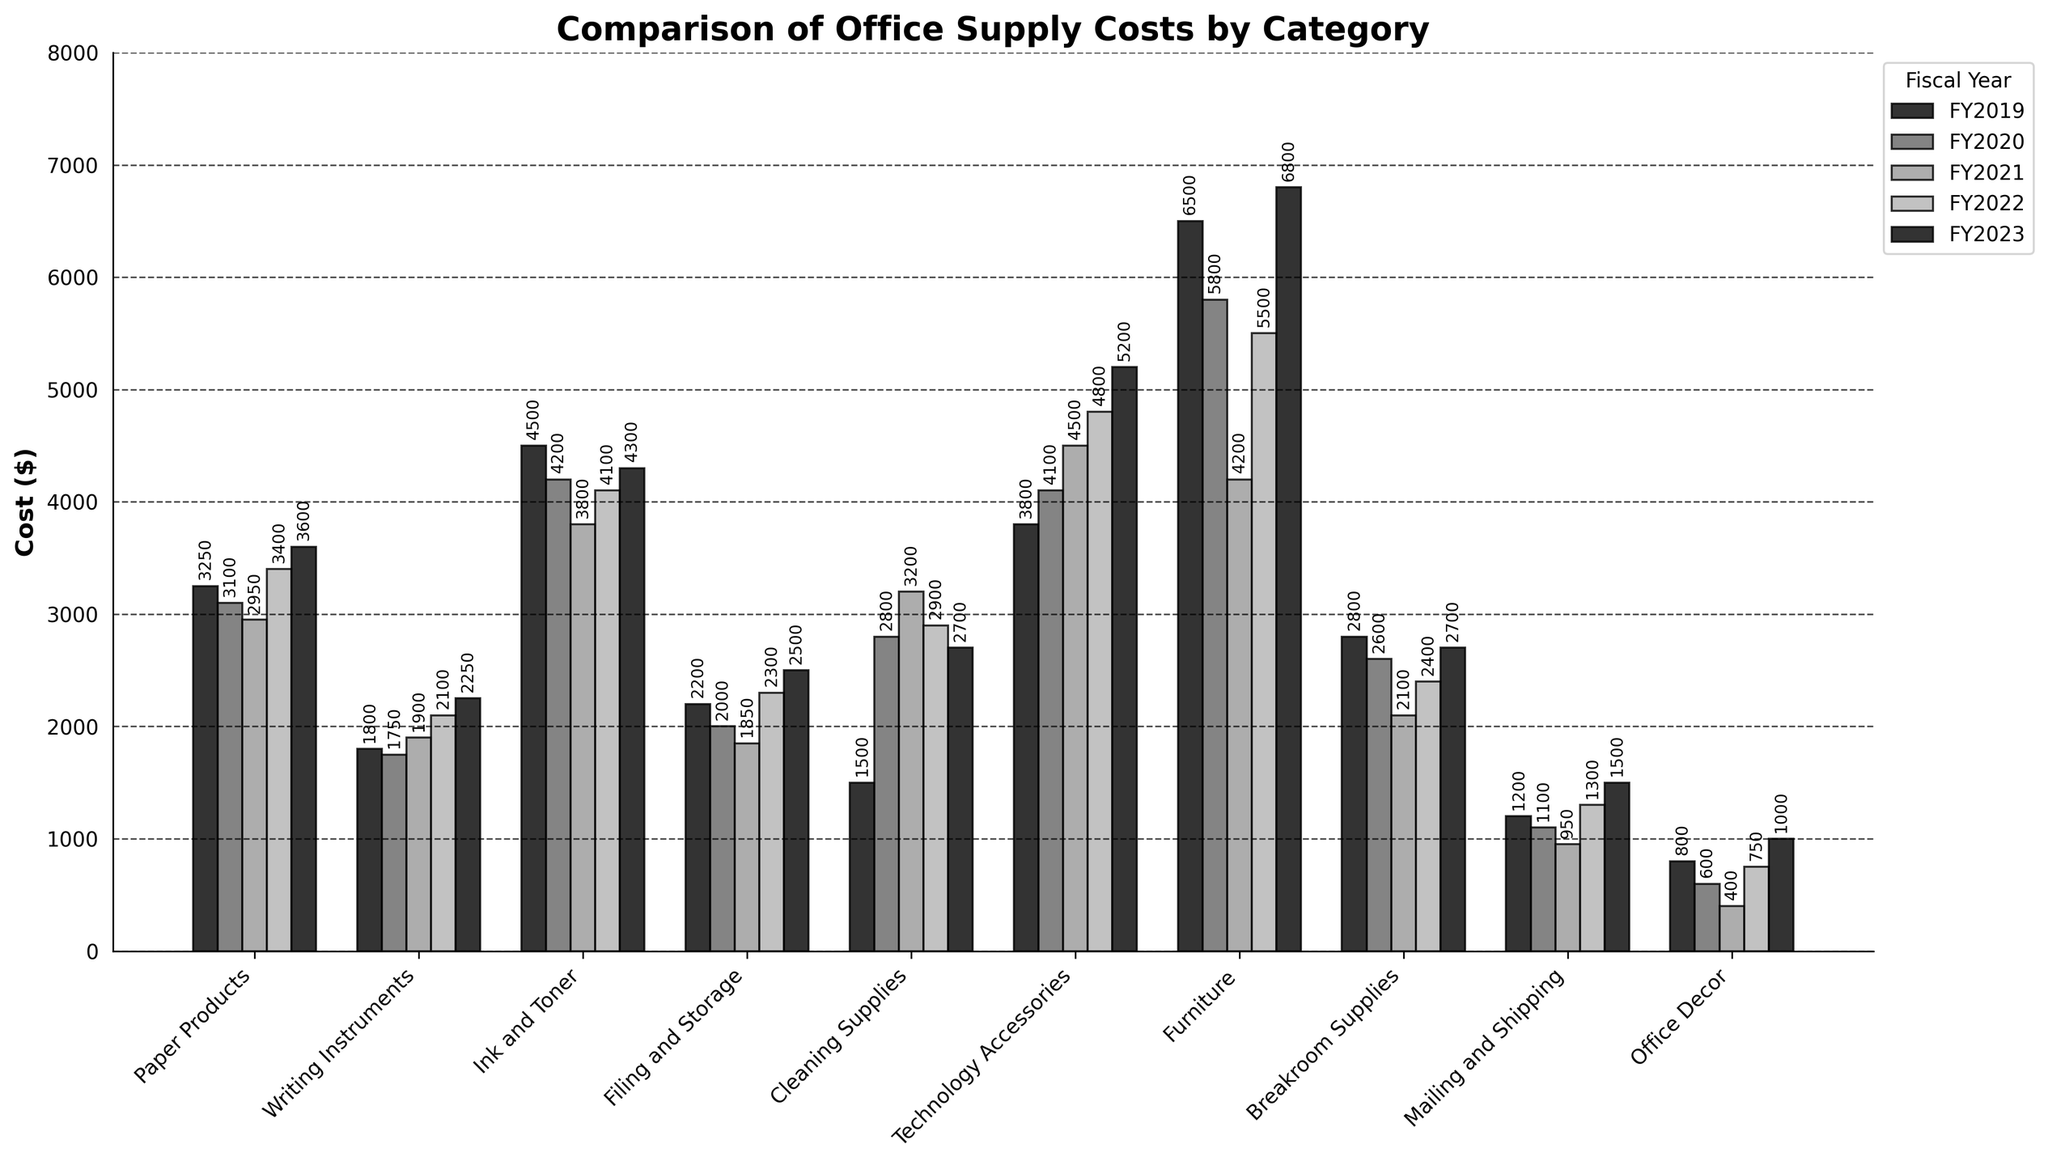What's the highest cost category in FY2023? Look for the tallest bar in FY2023. The 'Furniture' category has the tallest bar in FY2023, indicating the highest cost.
Answer: Furniture Which category had the most significant increase in cost from FY2019 to FY2023? Compare each category's cost in FY2019 and FY2023. The category with the largest difference is 'Furniture' which increased from 6500 to 6800.
Answer: Furniture What is the total cost for 'Cleaning Supplies' between FY2019 and FY2023? Add the costs for 'Cleaning Supplies' for each fiscal year: 1500 (FY2019) + 2800 (FY2020) + 3200 (FY2021) + 2900 (FY2022) + 2700 (FY2023) = 13100.
Answer: 13100 Which categories saw a cost decrease from FY2019 to FY2023? Compare the costs of each category from FY2019 to FY2023. Categories that decreased include 'Writing Instruments', 'Ink and Toner', 'Filing and Storage', 'Breakroom Supplies', and 'Office Decor'.
Answer: Writing Instruments, Ink and Toner, Filing and Storage, Breakroom Supplies, Office Decor What is the average cost for 'Technology Accessories' over the last 5 fiscal years? Add the costs for 'Technology Accessories' and divide by 5: (3800 + 4100 + 4500 + 4800 + 5200) / 5 = 4480.
Answer: 4480 Which category had the lowest cost in FY2021? Look for the shortest bar in FY2021. The 'Office Decor' category has the shortest bar in FY2021, indicating the lowest cost.
Answer: Office Decor What is the difference in cost between 'Furniture' and 'Technology Accessories' in FY2023? Subtract the cost of 'Technology Accessories' from the cost of 'Furniture' in FY2023: 6800 - 5200 = 1600.
Answer: 1600 Compare the cost trend for 'Paper Products' and 'Writing Instruments' over the 5 fiscal years. Which one had a more stable cost? Examine the bars for 'Paper Products' and 'Writing Instruments'. 'Writing Instruments' had smaller variations in cost over the years, indicating more stability.
Answer: Writing Instruments 